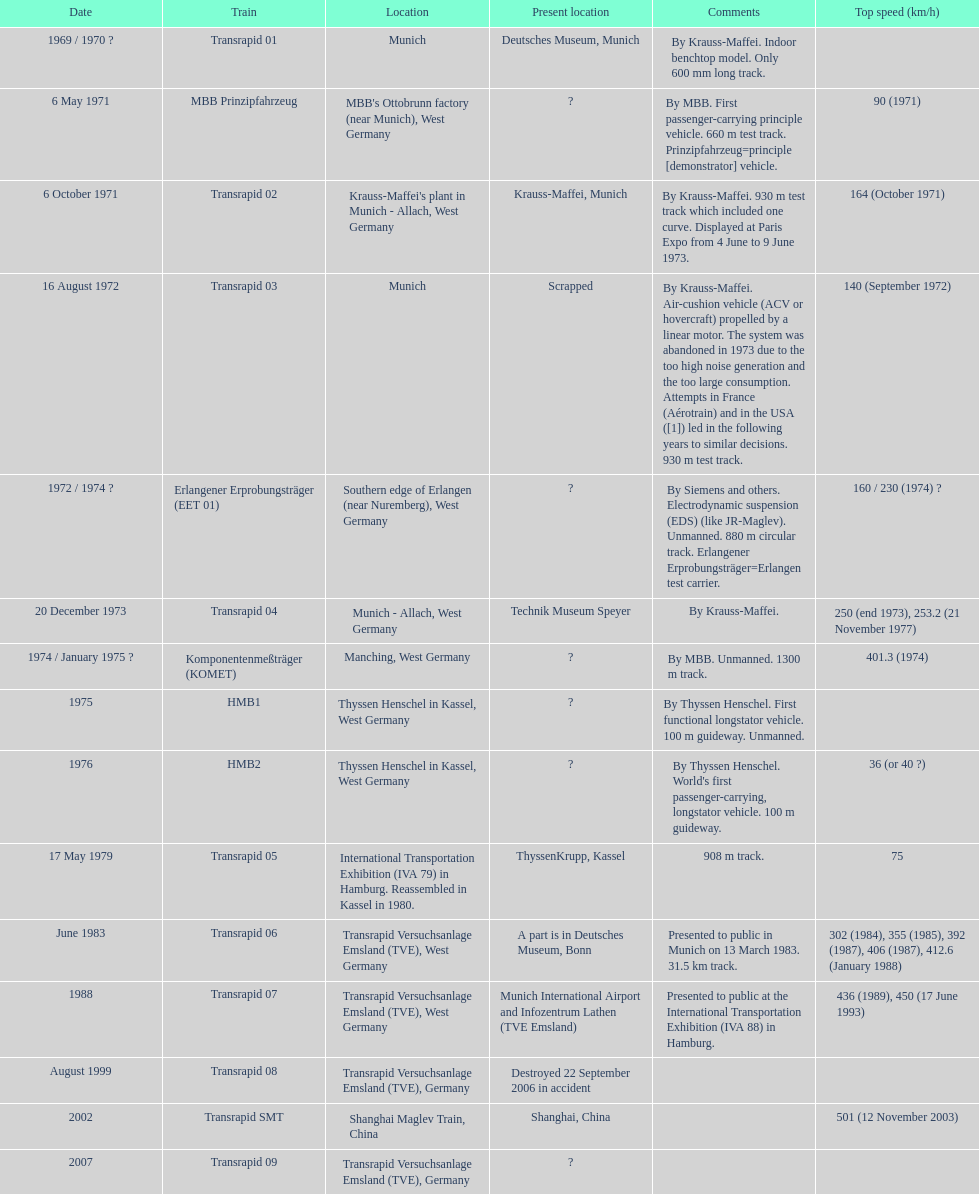How many trains mentioned possess the same speed as the hmb2? 0. 